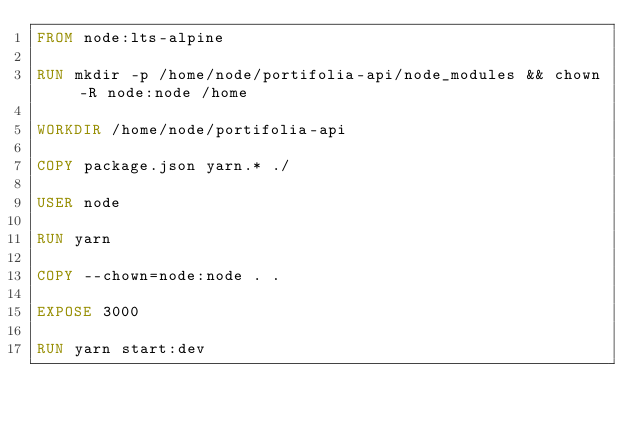Convert code to text. <code><loc_0><loc_0><loc_500><loc_500><_Dockerfile_>FROM node:lts-alpine

RUN mkdir -p /home/node/portifolia-api/node_modules && chown -R node:node /home

WORKDIR /home/node/portifolia-api

COPY package.json yarn.* ./

USER node

RUN yarn

COPY --chown=node:node . .

EXPOSE 3000

RUN yarn start:dev
</code> 